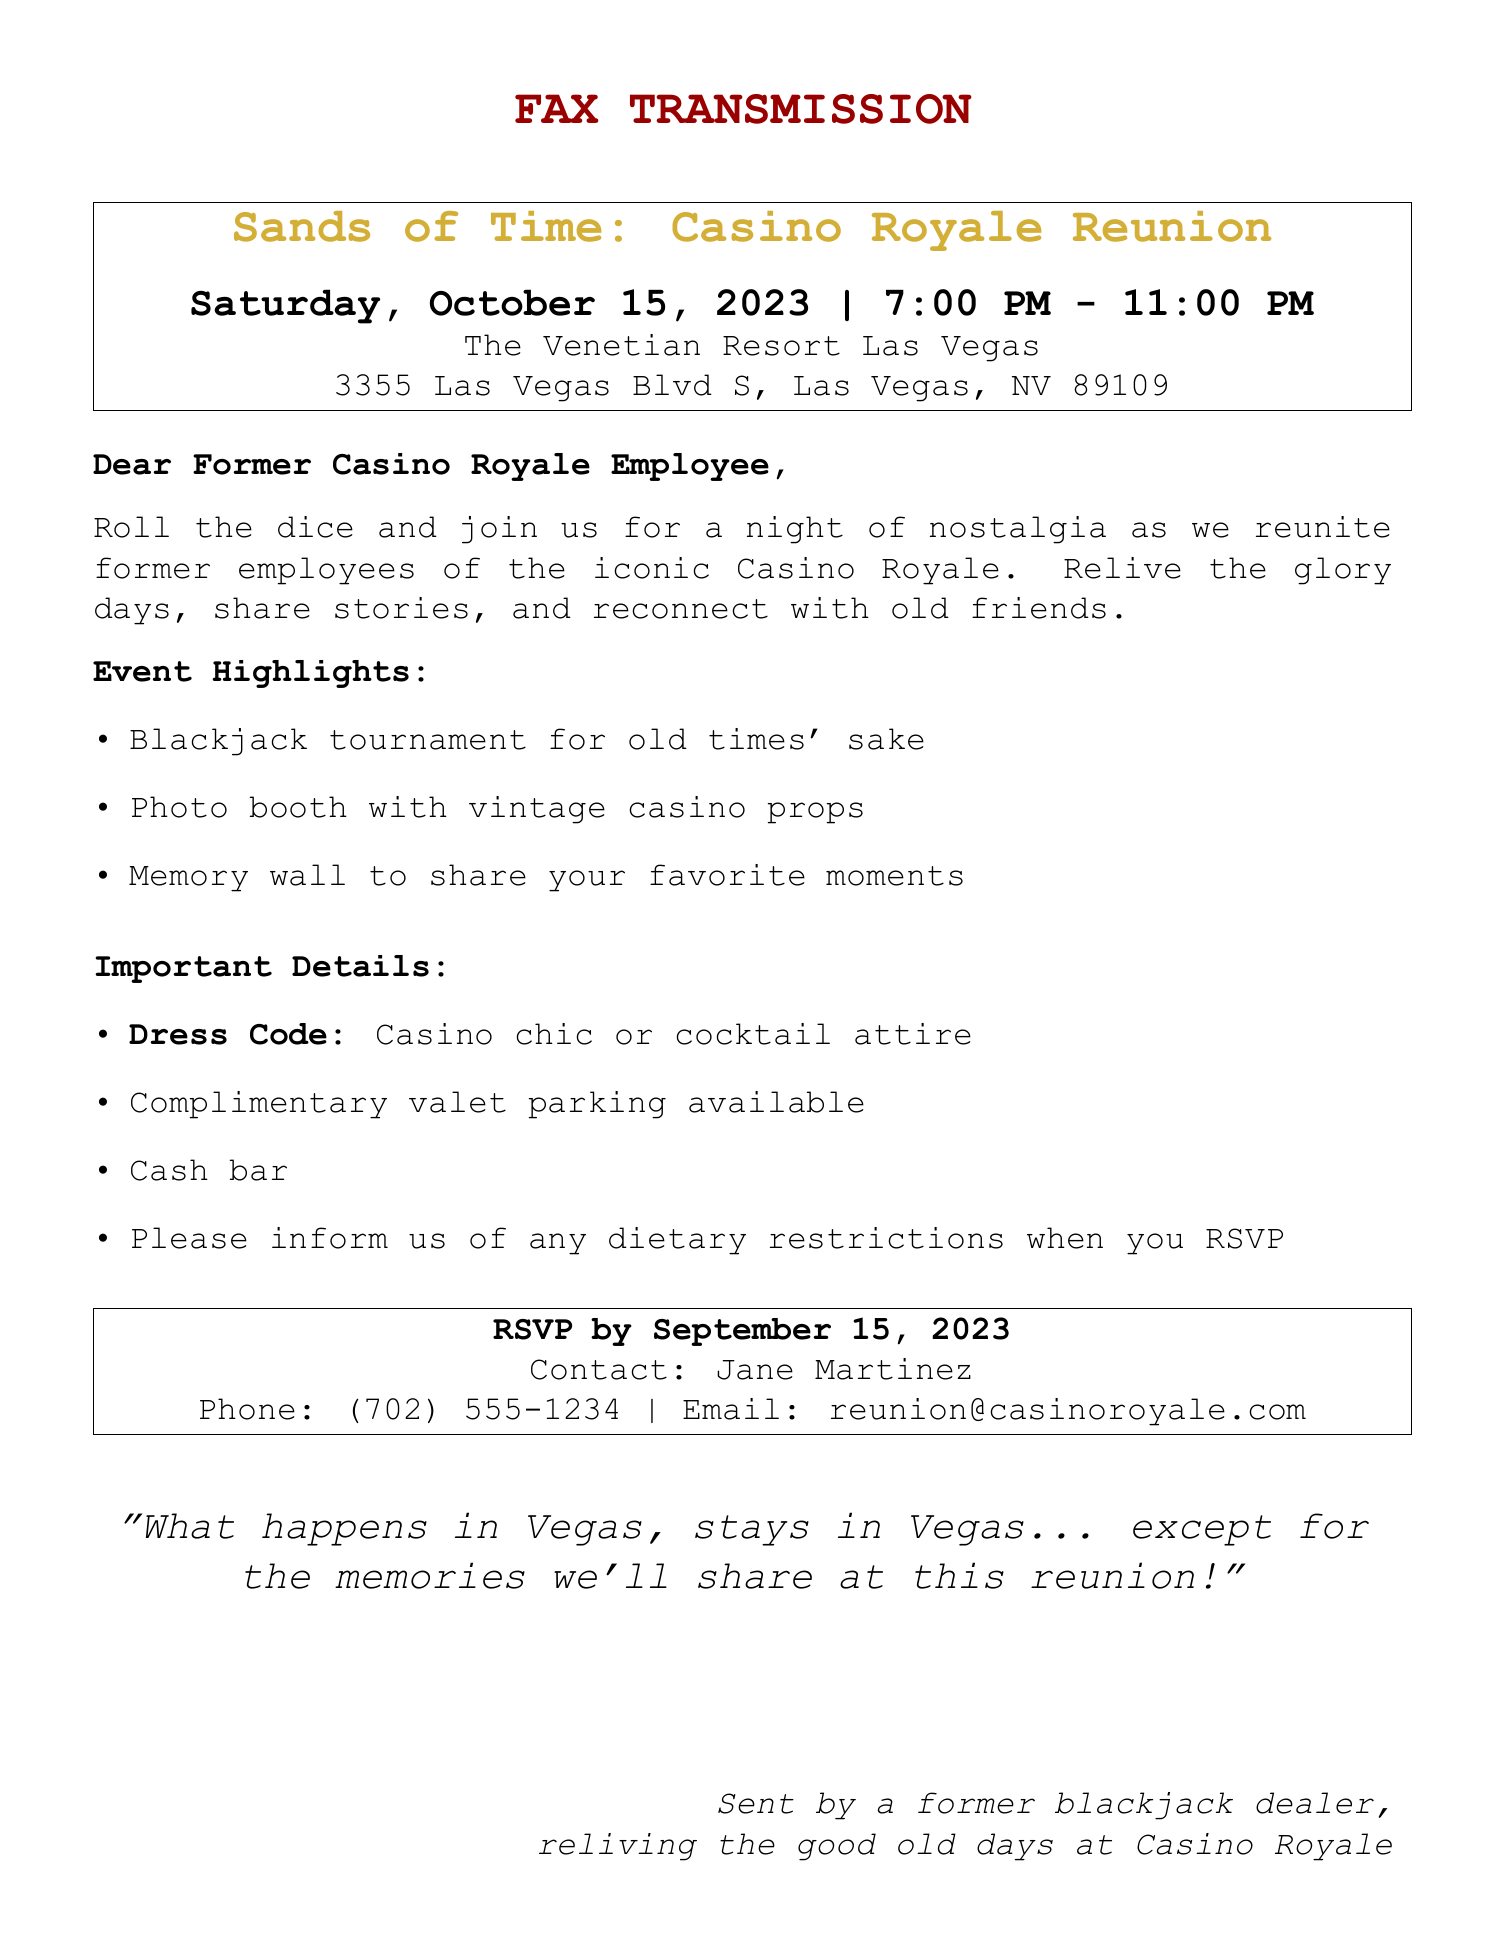What is the title of the event? The title of the event is clearly stated as "Sands of Time: Casino Royale Reunion."
Answer: Sands of Time: Casino Royale Reunion When is the reunion event scheduled? The date of the event is provided in the document as Saturday, October 15, 2023.
Answer: Saturday, October 15, 2023 What time does the reunion start? The start time of the event is specified as 7:00 PM.
Answer: 7:00 PM Where is the venue located? The document provides the location as The Venetian Resort Las Vegas and includes the address.
Answer: The Venetian Resort Las Vegas Who should attendees contact to RSVP? The document mentions Jane Martinez as the contact person for RSVP.
Answer: Jane Martinez What is the RSVP deadline? The RSVP deadline is explicitly stated in the document as September 15, 2023.
Answer: September 15, 2023 Is there a dress code for the event? The document indicates that the dress code is "Casino chic or cocktail attire."
Answer: Casino chic or cocktail attire What kind of parking is available at the venue? The document states that complimentary valet parking is available.
Answer: Complimentary valet parking What will attendees be sharing at the memory wall? The document mentions sharing favorite moments at the memory wall.
Answer: Favorite moments 